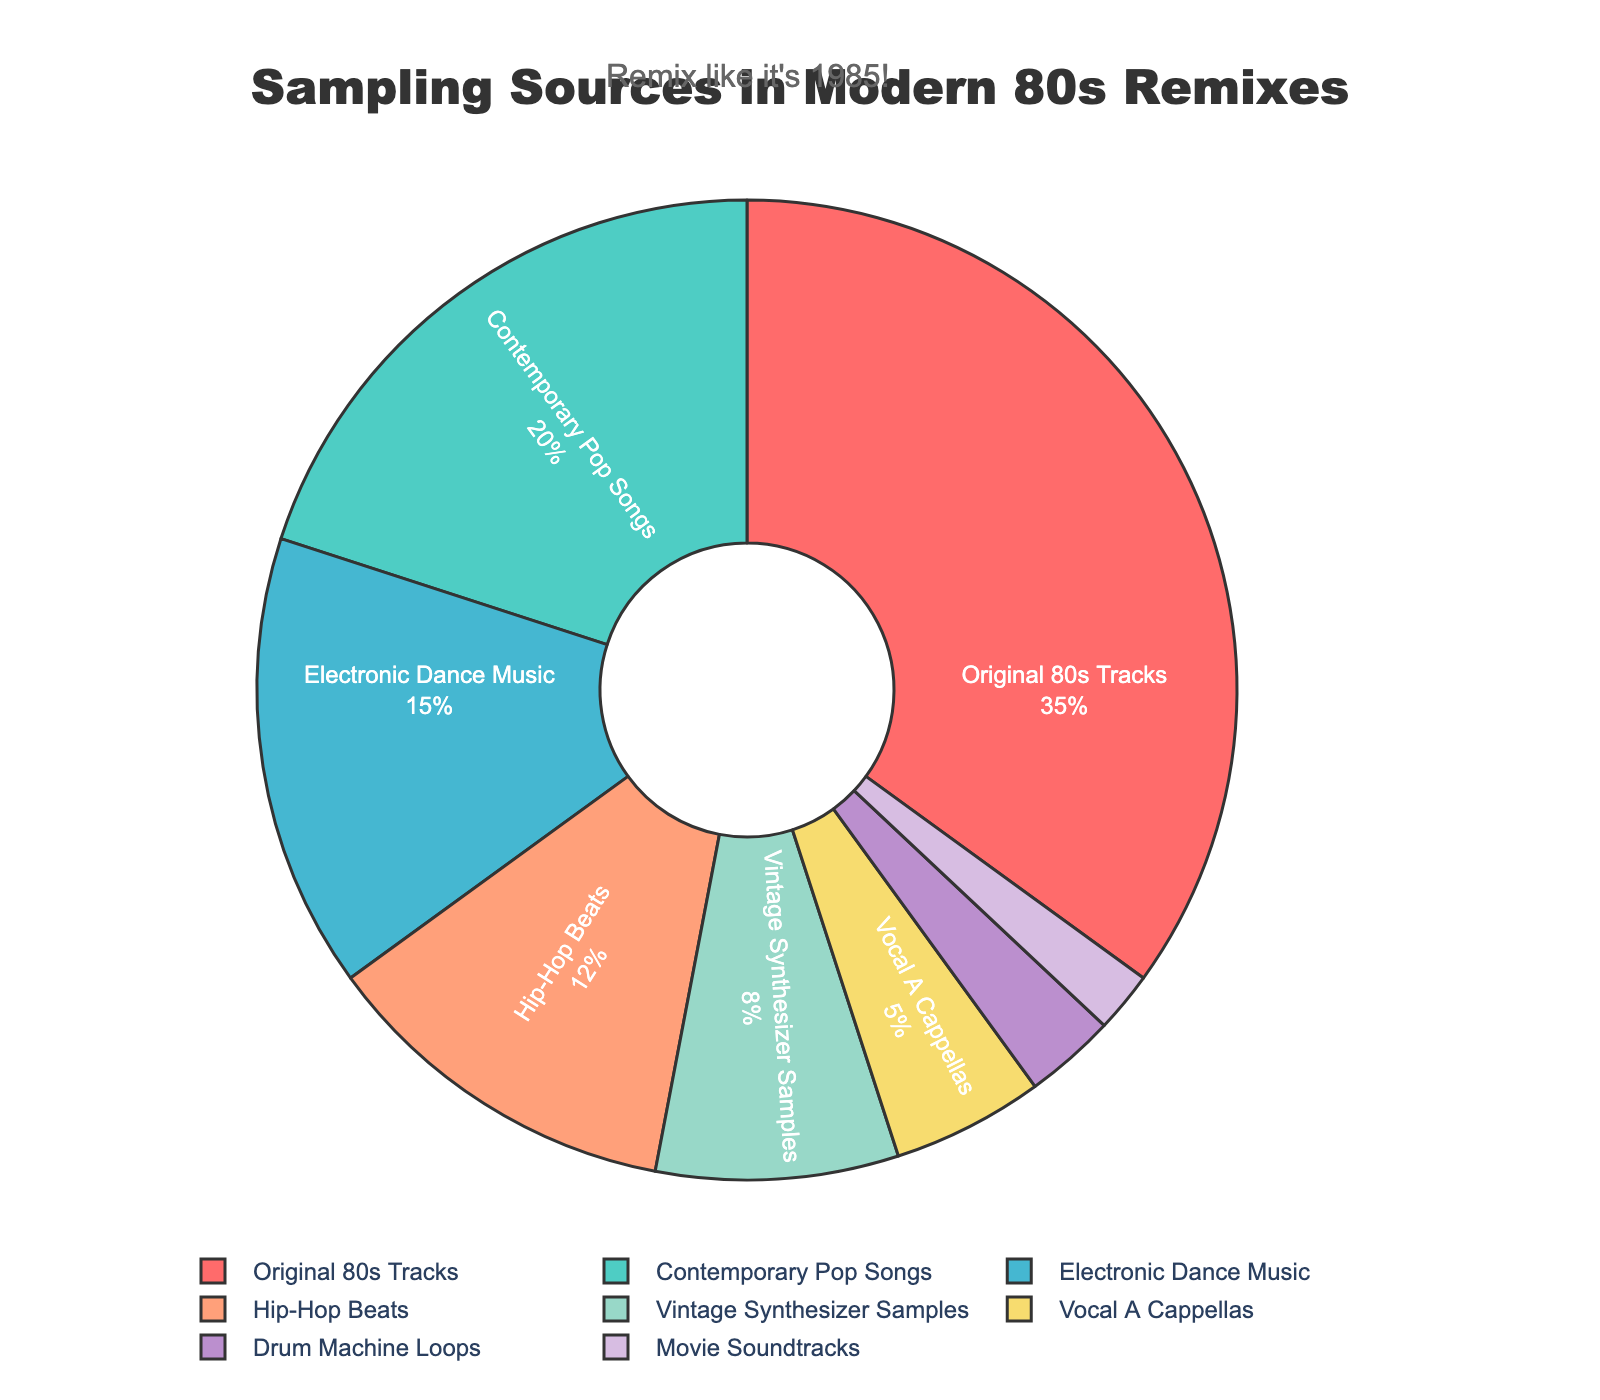What's the largest source of sampling in modern remixes of 80s tracks? To identify the largest source, look at the segment with the highest percentage. This segment corresponds to "Original 80s Tracks" at 35%.
Answer: Original 80s Tracks How much more do Original 80s Tracks contribute compared to Contemporary Pop Songs? Subtract the percentage of Contemporary Pop Songs from the percentage of Original 80s Tracks. 35% - 20% = 15%.
Answer: 15% What are the total percentage contributions of Vintage Synthesizer Samples, Vocal A Cappellas, Drum Machine Loops, and Movie Soundtracks combined? Sum up the percentages of the four sources. 8% + 5% + 3% + 2% = 18%.
Answer: 18% Which sampling source has the smallest percentage, and what is that percentage? The smallest percentage is found by identifying the segment with the smallest value, which is "Movie Soundtracks" at 2%.
Answer: Movie Soundtracks, 2% Are Contemporary Pop Songs or Electronic Dance Music used more in modern remixes of 80s tracks? Compare the percentages of Contemporary Pop Songs (20%) and Electronic Dance Music (15%). Since 20% > 15%, Contemporary Pop Songs are used more.
Answer: Contemporary Pop Songs What is the sum of all the percentages represented in the pie chart? Add up all the percentages: 35% + 20% + 15% + 12% + 8% + 5% + 3% + 2% = 100%.
Answer: 100% How do Hip-Hop Beats compare with Vintage Synthesizer Samples in terms of percentage contribution? Compare the percentages: Hip-Hop Beats are at 12% and Vintage Synthesizer Samples are at 8%. Since 12% > 8%, Hip-Hop Beats contribute more.
Answer: Hip-Hop Beats Among the sampling sources, which one is represented in purple color? Based on the natural color association and the given list, "Drum Machine Loops" is shown in purple.
Answer: Drum Machine Loops 